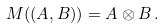<formula> <loc_0><loc_0><loc_500><loc_500>M ( ( A , B ) ) = A \otimes B \, .</formula> 